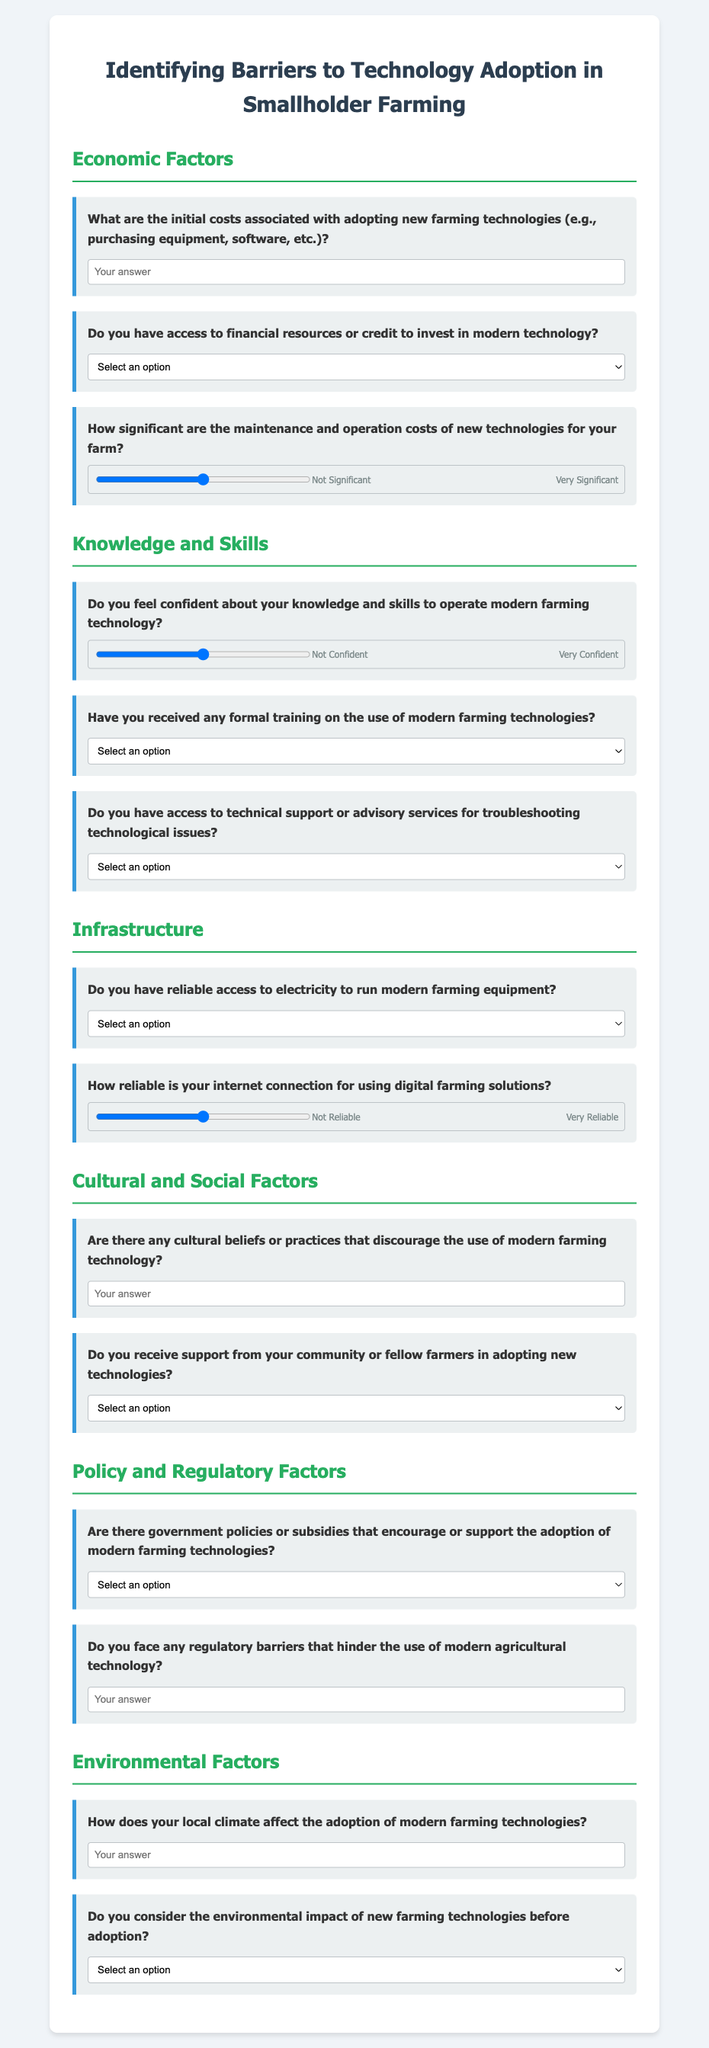What is the title of the questionnaire? The title is indicated at the top of the document, summarizing its content and purpose.
Answer: Identifying Barriers to Technology Adoption in Smallholder Farming What are the three main sections for barriers identified in the questionnaire? The document lists sections that categorize different types of barriers to technology adoption in farming.
Answer: Economic Factors, Knowledge and Skills, Infrastructure, Cultural and Social Factors, Policy and Regulatory Factors, Environmental Factors What option indicates access to financial resources for modern technology? The possible selections provide insights into the respondent's financial capacity regarding technology adoption.
Answer: Yes, No, Sometimes What kind of support is available for troubleshooting technological issues? The options indicate levels of access to technical support for using modern technology in farming.
Answer: Yes, Regular Access, Yes, Limited Access, No Access What scale is used to measure confidence in operating modern farming technology? The questionnaire employs a numerical range to assess the confidence level of farmers in handling modern technology.
Answer: 1 to 5 What is one cultural barrier that might discourage technology use according to the questionnaire? The document asks for a narrative response about cultural beliefs impacting technology adoption.
Answer: [Short answer expected from respondent] What is the scale for evaluating the reliability of internet connection? The document specifies a range to gauge the reliability of internet connectivity for digital farming solutions.
Answer: 1 to 5 What aspect of government support is questioned under policy factors? The questionnaire inquires about government initiatives that could facilitate or hinder technology adoption.
Answer: Government policies or subsidies In the section for environmental factors, what is asked about the local climate? The document explores the interplay between the local climate and the adoption of farming technologies through a specific query.
Answer: How does your local climate affect the adoption of modern farming technologies? 